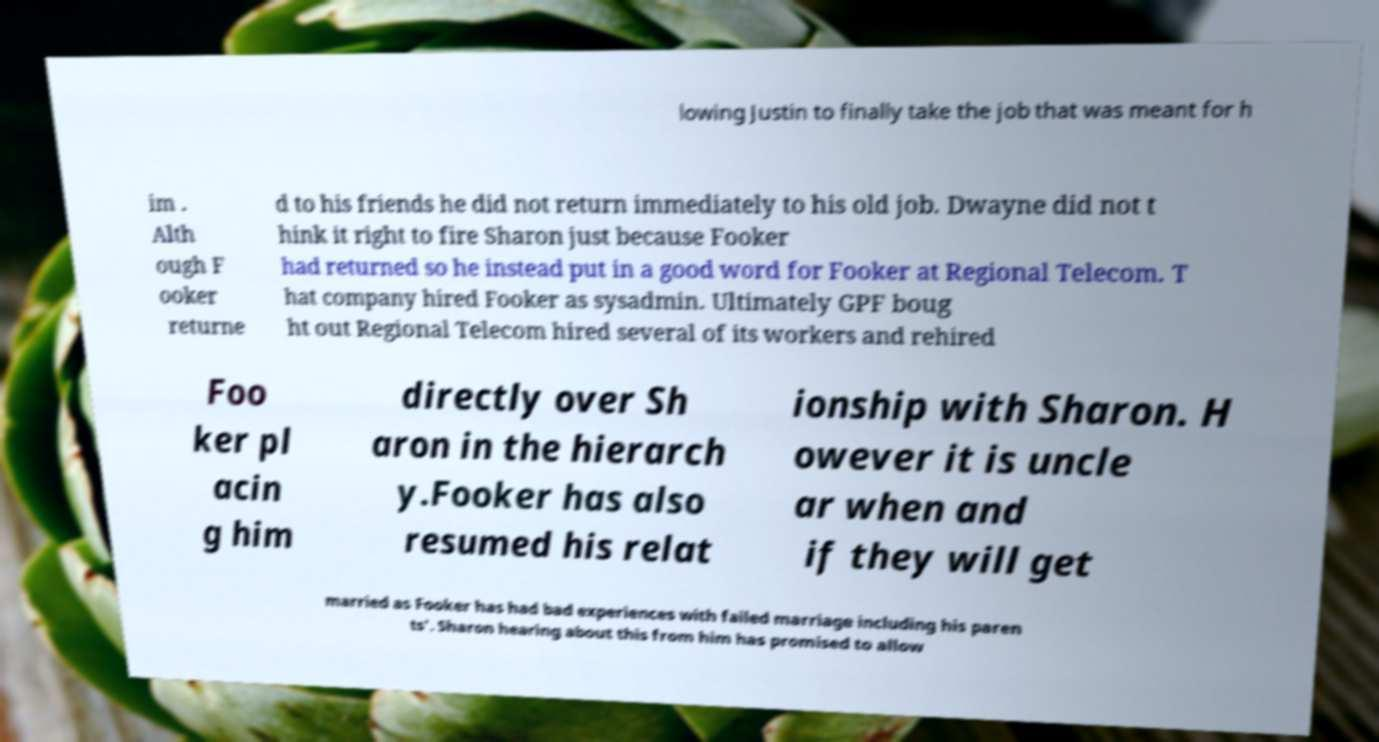What messages or text are displayed in this image? I need them in a readable, typed format. lowing Justin to finally take the job that was meant for h im . Alth ough F ooker returne d to his friends he did not return immediately to his old job. Dwayne did not t hink it right to fire Sharon just because Fooker had returned so he instead put in a good word for Fooker at Regional Telecom. T hat company hired Fooker as sysadmin. Ultimately GPF boug ht out Regional Telecom hired several of its workers and rehired Foo ker pl acin g him directly over Sh aron in the hierarch y.Fooker has also resumed his relat ionship with Sharon. H owever it is uncle ar when and if they will get married as Fooker has had bad experiences with failed marriage including his paren ts'. Sharon hearing about this from him has promised to allow 